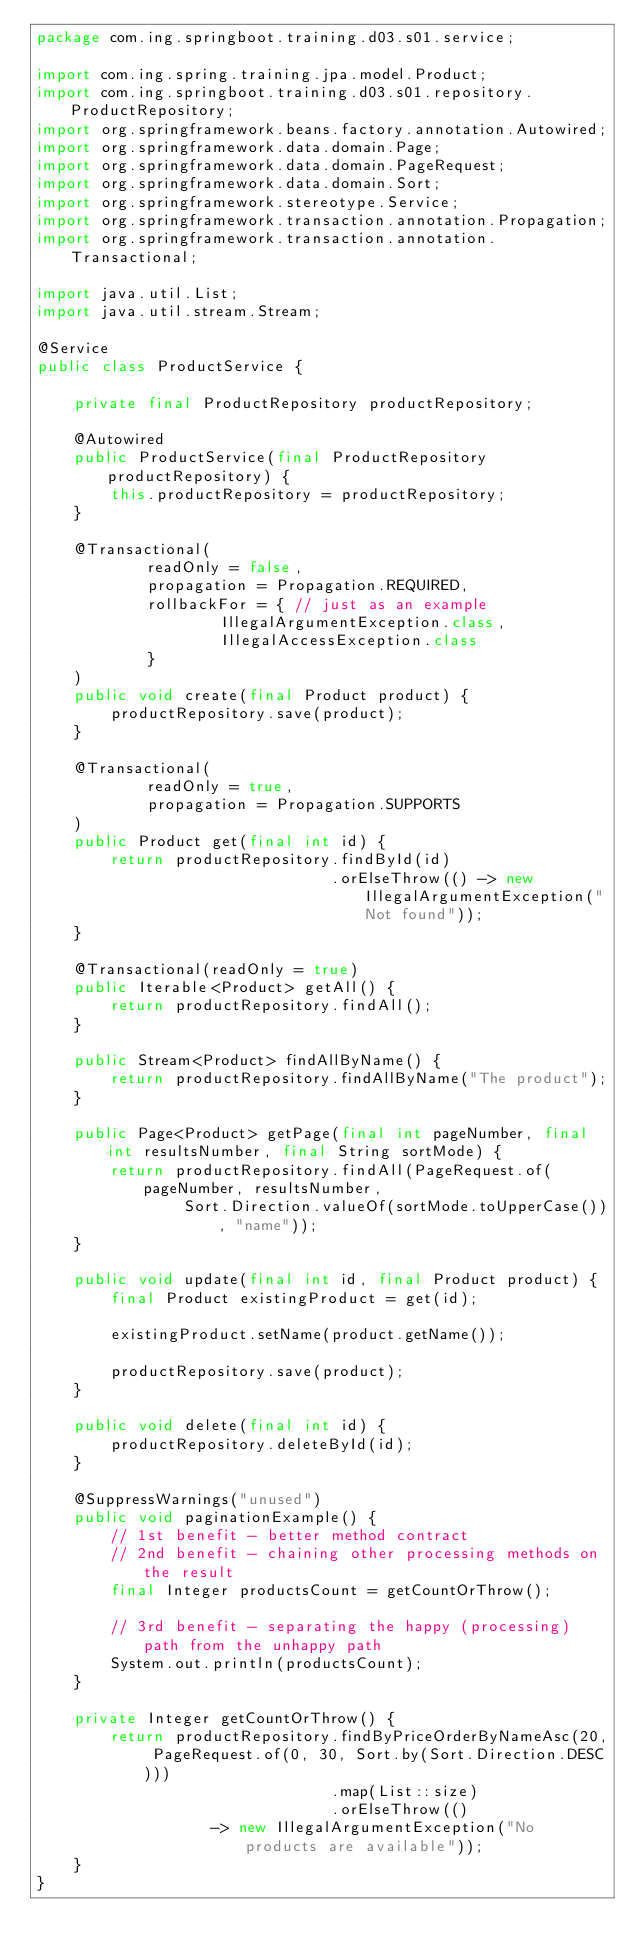Convert code to text. <code><loc_0><loc_0><loc_500><loc_500><_Java_>package com.ing.springboot.training.d03.s01.service;

import com.ing.spring.training.jpa.model.Product;
import com.ing.springboot.training.d03.s01.repository.ProductRepository;
import org.springframework.beans.factory.annotation.Autowired;
import org.springframework.data.domain.Page;
import org.springframework.data.domain.PageRequest;
import org.springframework.data.domain.Sort;
import org.springframework.stereotype.Service;
import org.springframework.transaction.annotation.Propagation;
import org.springframework.transaction.annotation.Transactional;

import java.util.List;
import java.util.stream.Stream;

@Service
public class ProductService {

    private final ProductRepository productRepository;

    @Autowired
    public ProductService(final ProductRepository productRepository) {
        this.productRepository = productRepository;
    }

    @Transactional(
            readOnly = false,
            propagation = Propagation.REQUIRED,
            rollbackFor = { // just as an example
                    IllegalArgumentException.class,
                    IllegalAccessException.class
            }
    )
    public void create(final Product product) {
        productRepository.save(product);
    }

    @Transactional(
            readOnly = true,
            propagation = Propagation.SUPPORTS
    )
    public Product get(final int id) {
        return productRepository.findById(id)
                                .orElseThrow(() -> new IllegalArgumentException("Not found"));
    }

    @Transactional(readOnly = true)
    public Iterable<Product> getAll() {
        return productRepository.findAll();
    }

    public Stream<Product> findAllByName() {
        return productRepository.findAllByName("The product");
    }

    public Page<Product> getPage(final int pageNumber, final int resultsNumber, final String sortMode) {
        return productRepository.findAll(PageRequest.of(pageNumber, resultsNumber,
                Sort.Direction.valueOf(sortMode.toUpperCase()), "name"));
    }

    public void update(final int id, final Product product) {
        final Product existingProduct = get(id);

        existingProduct.setName(product.getName());

        productRepository.save(product);
    }

    public void delete(final int id) {
        productRepository.deleteById(id);
    }

    @SuppressWarnings("unused")
    public void paginationExample() {
        // 1st benefit - better method contract
        // 2nd benefit - chaining other processing methods on the result
        final Integer productsCount = getCountOrThrow();

        // 3rd benefit - separating the happy (processing) path from the unhappy path
        System.out.println(productsCount);
    }

    private Integer getCountOrThrow() {
        return productRepository.findByPriceOrderByNameAsc(20, PageRequest.of(0, 30, Sort.by(Sort.Direction.DESC)))
                                .map(List::size)
                                .orElseThrow(()
                   -> new IllegalArgumentException("No products are available"));
    }
}
</code> 